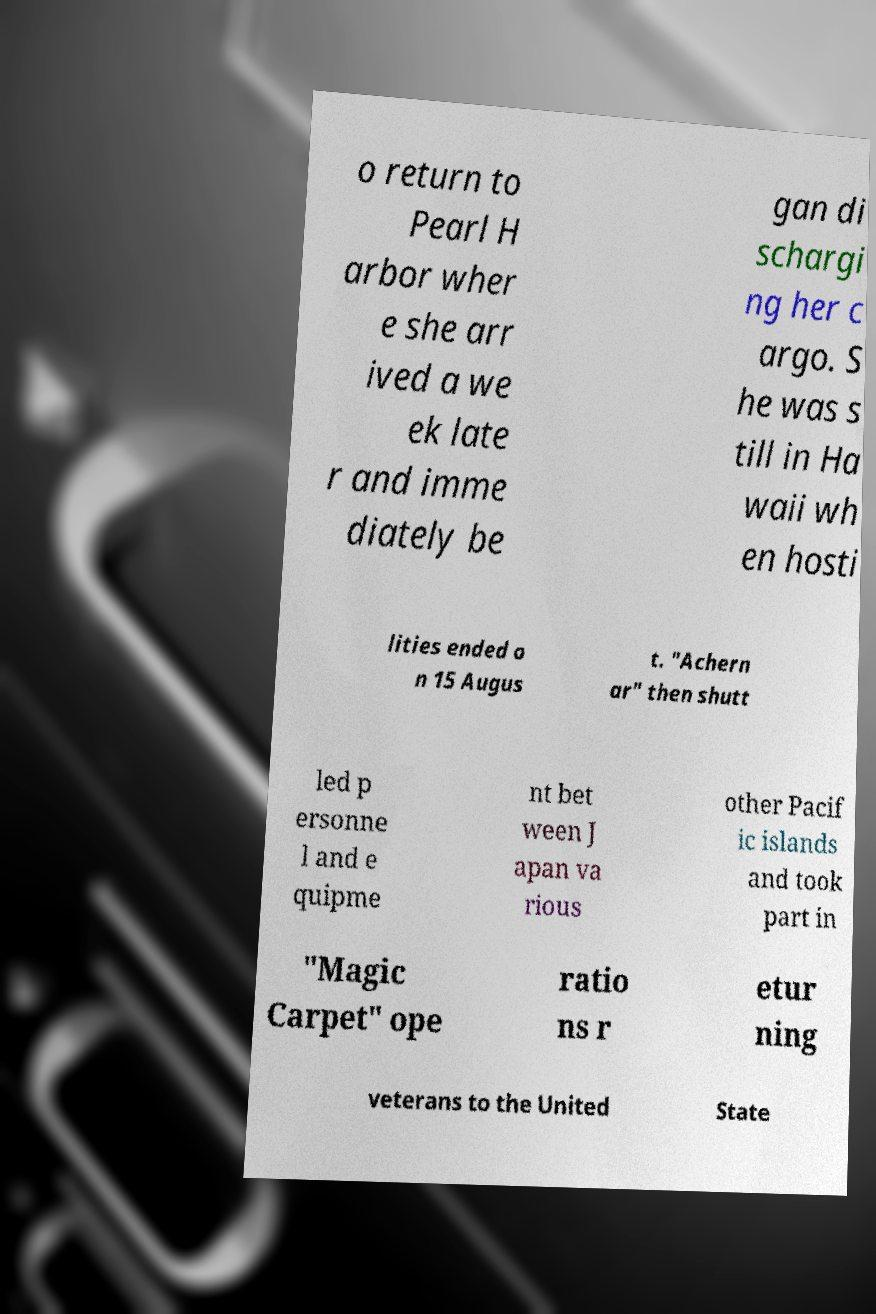Can you read and provide the text displayed in the image?This photo seems to have some interesting text. Can you extract and type it out for me? o return to Pearl H arbor wher e she arr ived a we ek late r and imme diately be gan di schargi ng her c argo. S he was s till in Ha waii wh en hosti lities ended o n 15 Augus t. "Achern ar" then shutt led p ersonne l and e quipme nt bet ween J apan va rious other Pacif ic islands and took part in "Magic Carpet" ope ratio ns r etur ning veterans to the United State 